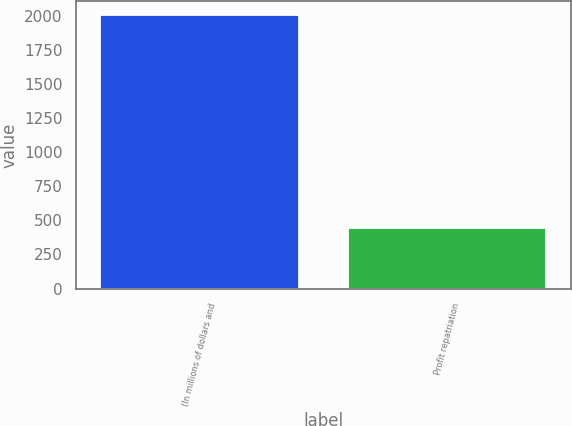<chart> <loc_0><loc_0><loc_500><loc_500><bar_chart><fcel>(In millions of dollars and<fcel>Profit repatriation<nl><fcel>2006<fcel>442<nl></chart> 